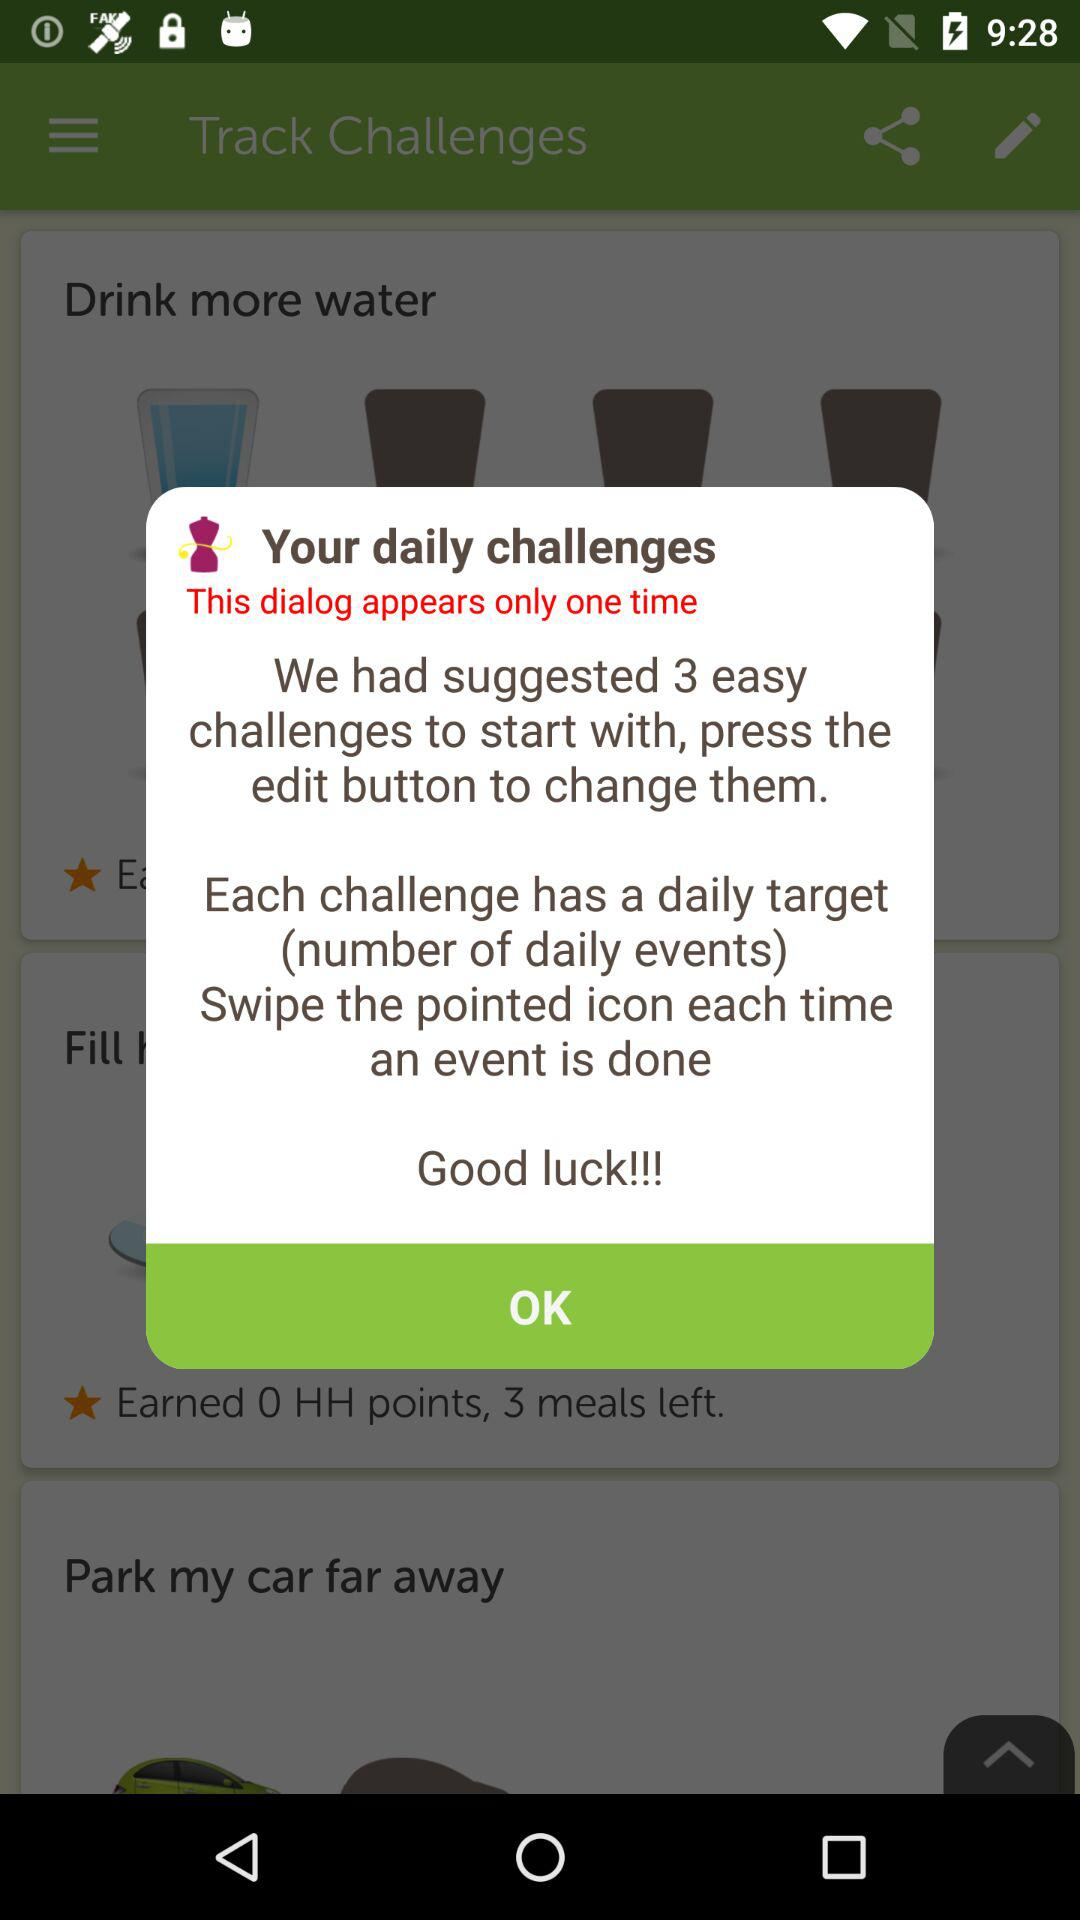How many challenges have we suggested? You have suggested 3 challenges. 